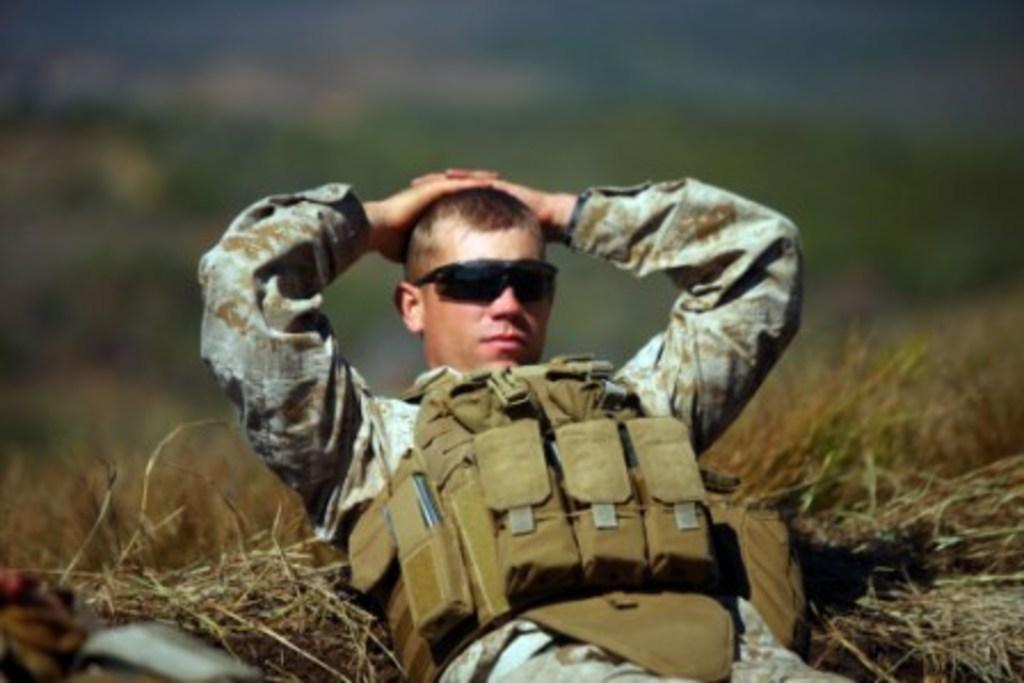How would you summarize this image in a sentence or two? In this image we can see a person lying on the grass. The background of the image is blurred. 